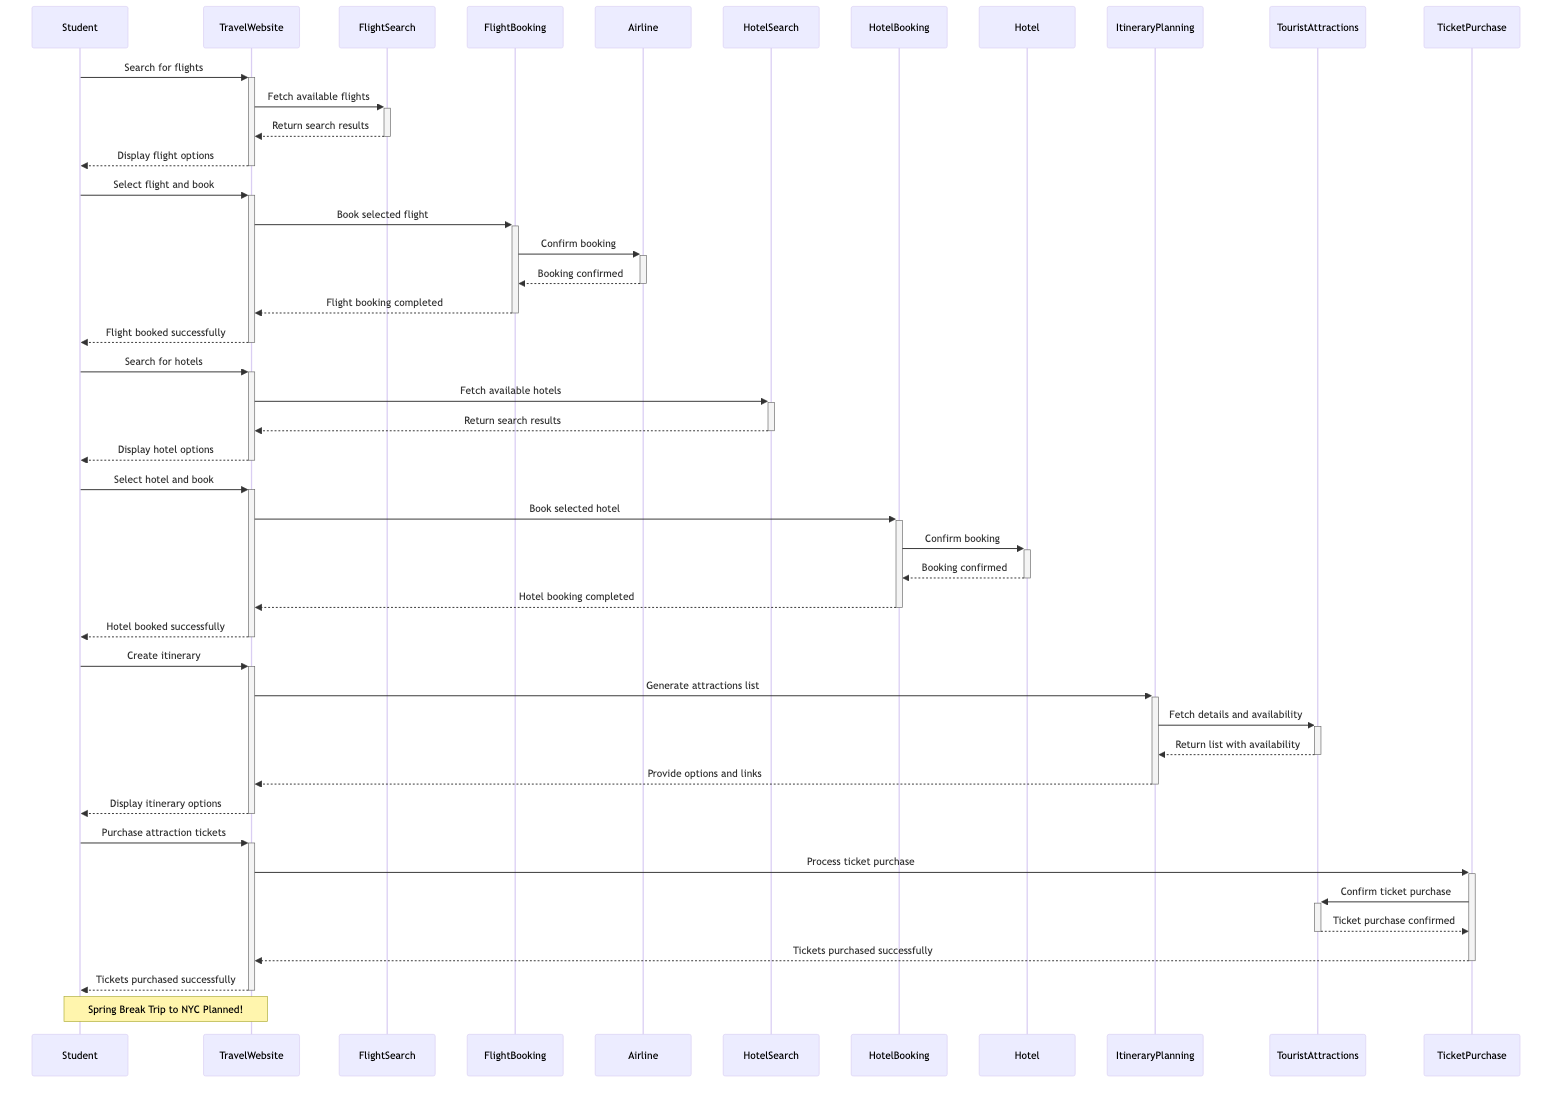What is the first action taken by the Student? The first action taken by the Student is to search for flights to New York City. This is indicated by the message from the Student to the TravelWebsite to initiate the flight search.
Answer: Search for flights from California to New York City How many actors are involved in this sequence diagram? There are five distinct actors participating in the sequence diagram: Student, TravelWebsite, Airline, Hotel, and TouristAttractions.
Answer: Five What does the TravelWebsite display to the Student after searching for flights? After fetching and processing the available flights, the TravelWebsite returns results by displaying flight options to the Student. This is indicated in the flow of messages from TravelWebsite to Student after the search results are processed.
Answer: Display flight options Which object does the Student interact with to create an itinerary? The Student interacts with the TravelWebsite to create an itinerary. This is shown by the Student's request to the TravelWebsite to generate a list of must-see attractions.
Answer: TravelWebsite What is the final confirmation received by the Student in this process? The final confirmation received by the Student is that the tickets for attractions are purchased successfully. This is confirmed last in the sequence after the ticket purchase process is completed.
Answer: Tickets purchased successfully How many times does the Student send a request for bookings? The Student sends a request twice for bookings: once for the flight booking and once for the hotel booking. The requests can be identified by the Student's messages to the TravelWebsite for selecting flights and hotels.
Answer: Two What message is sent from the TicketPurchase object to the TravelWebsite? The TicketPurchase object sends a message to the TravelWebsite confirming that the tickets have been purchased successfully. This is an important confirmation step in the sequence leading to finalization of the trip.
Answer: Tickets purchased successfully What does the ItineraryPlanning object require in order to generate a list of tourist attractions? The ItineraryPlanning object requires to fetch details and ticket availability from the TouristAttractions object, which is a necessary step for generating a comprehensive list for the Student.
Answer: Fetch details and tickets availability How is the booking confirmed for flights and hotels? The booking is confirmed for flights and hotels through a confirmation message between the FlightBooking/HotelBooking objects and the Airline/Hotel, respectively. The confirmation from the Airline and Hotel is then returned to the TravelWebsite.
Answer: Booking confirmed 